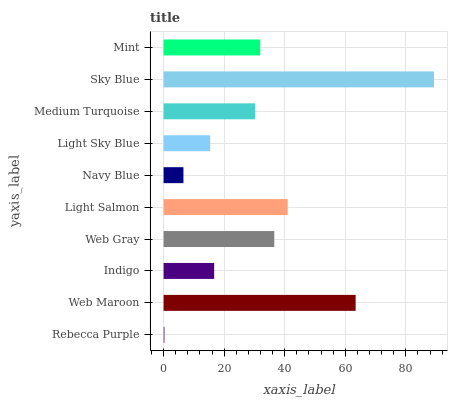Is Rebecca Purple the minimum?
Answer yes or no. Yes. Is Sky Blue the maximum?
Answer yes or no. Yes. Is Web Maroon the minimum?
Answer yes or no. No. Is Web Maroon the maximum?
Answer yes or no. No. Is Web Maroon greater than Rebecca Purple?
Answer yes or no. Yes. Is Rebecca Purple less than Web Maroon?
Answer yes or no. Yes. Is Rebecca Purple greater than Web Maroon?
Answer yes or no. No. Is Web Maroon less than Rebecca Purple?
Answer yes or no. No. Is Mint the high median?
Answer yes or no. Yes. Is Medium Turquoise the low median?
Answer yes or no. Yes. Is Medium Turquoise the high median?
Answer yes or no. No. Is Navy Blue the low median?
Answer yes or no. No. 